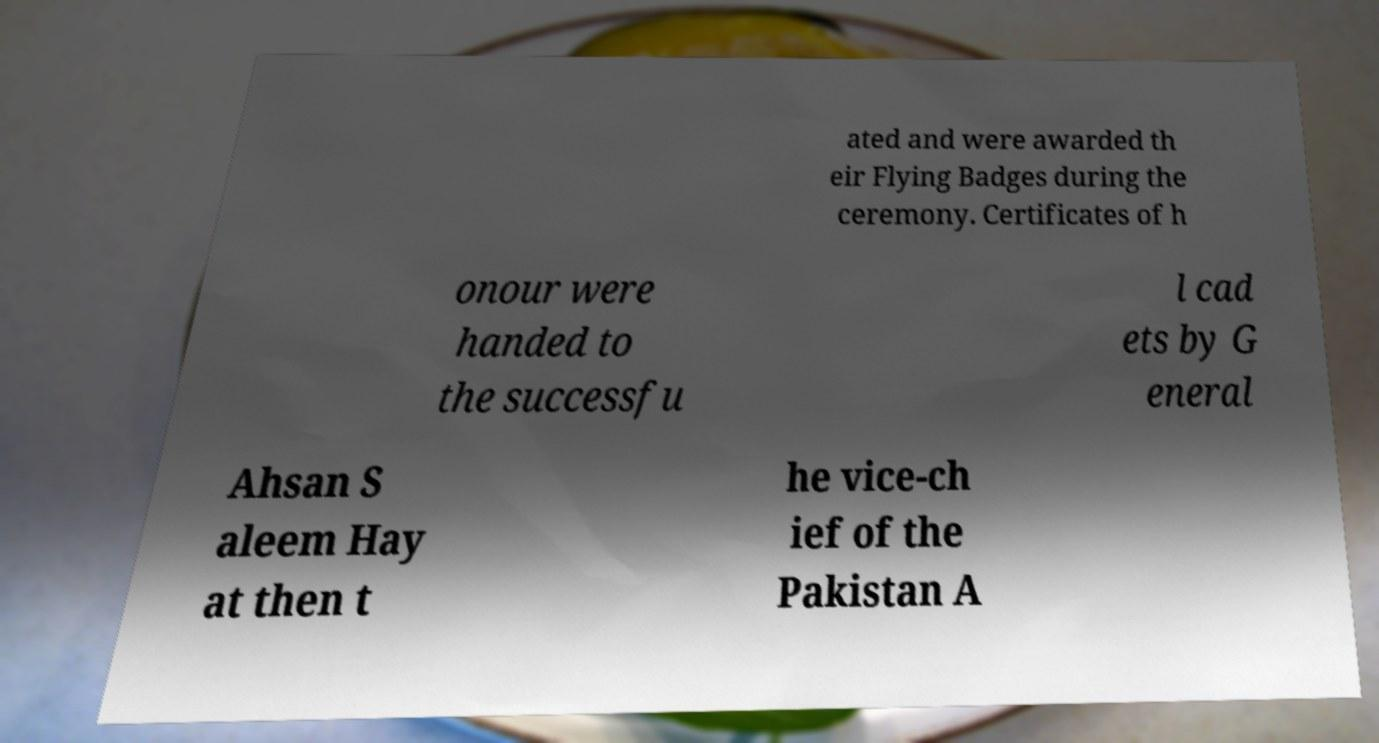Can you read and provide the text displayed in the image?This photo seems to have some interesting text. Can you extract and type it out for me? ated and were awarded th eir Flying Badges during the ceremony. Certificates of h onour were handed to the successfu l cad ets by G eneral Ahsan S aleem Hay at then t he vice-ch ief of the Pakistan A 